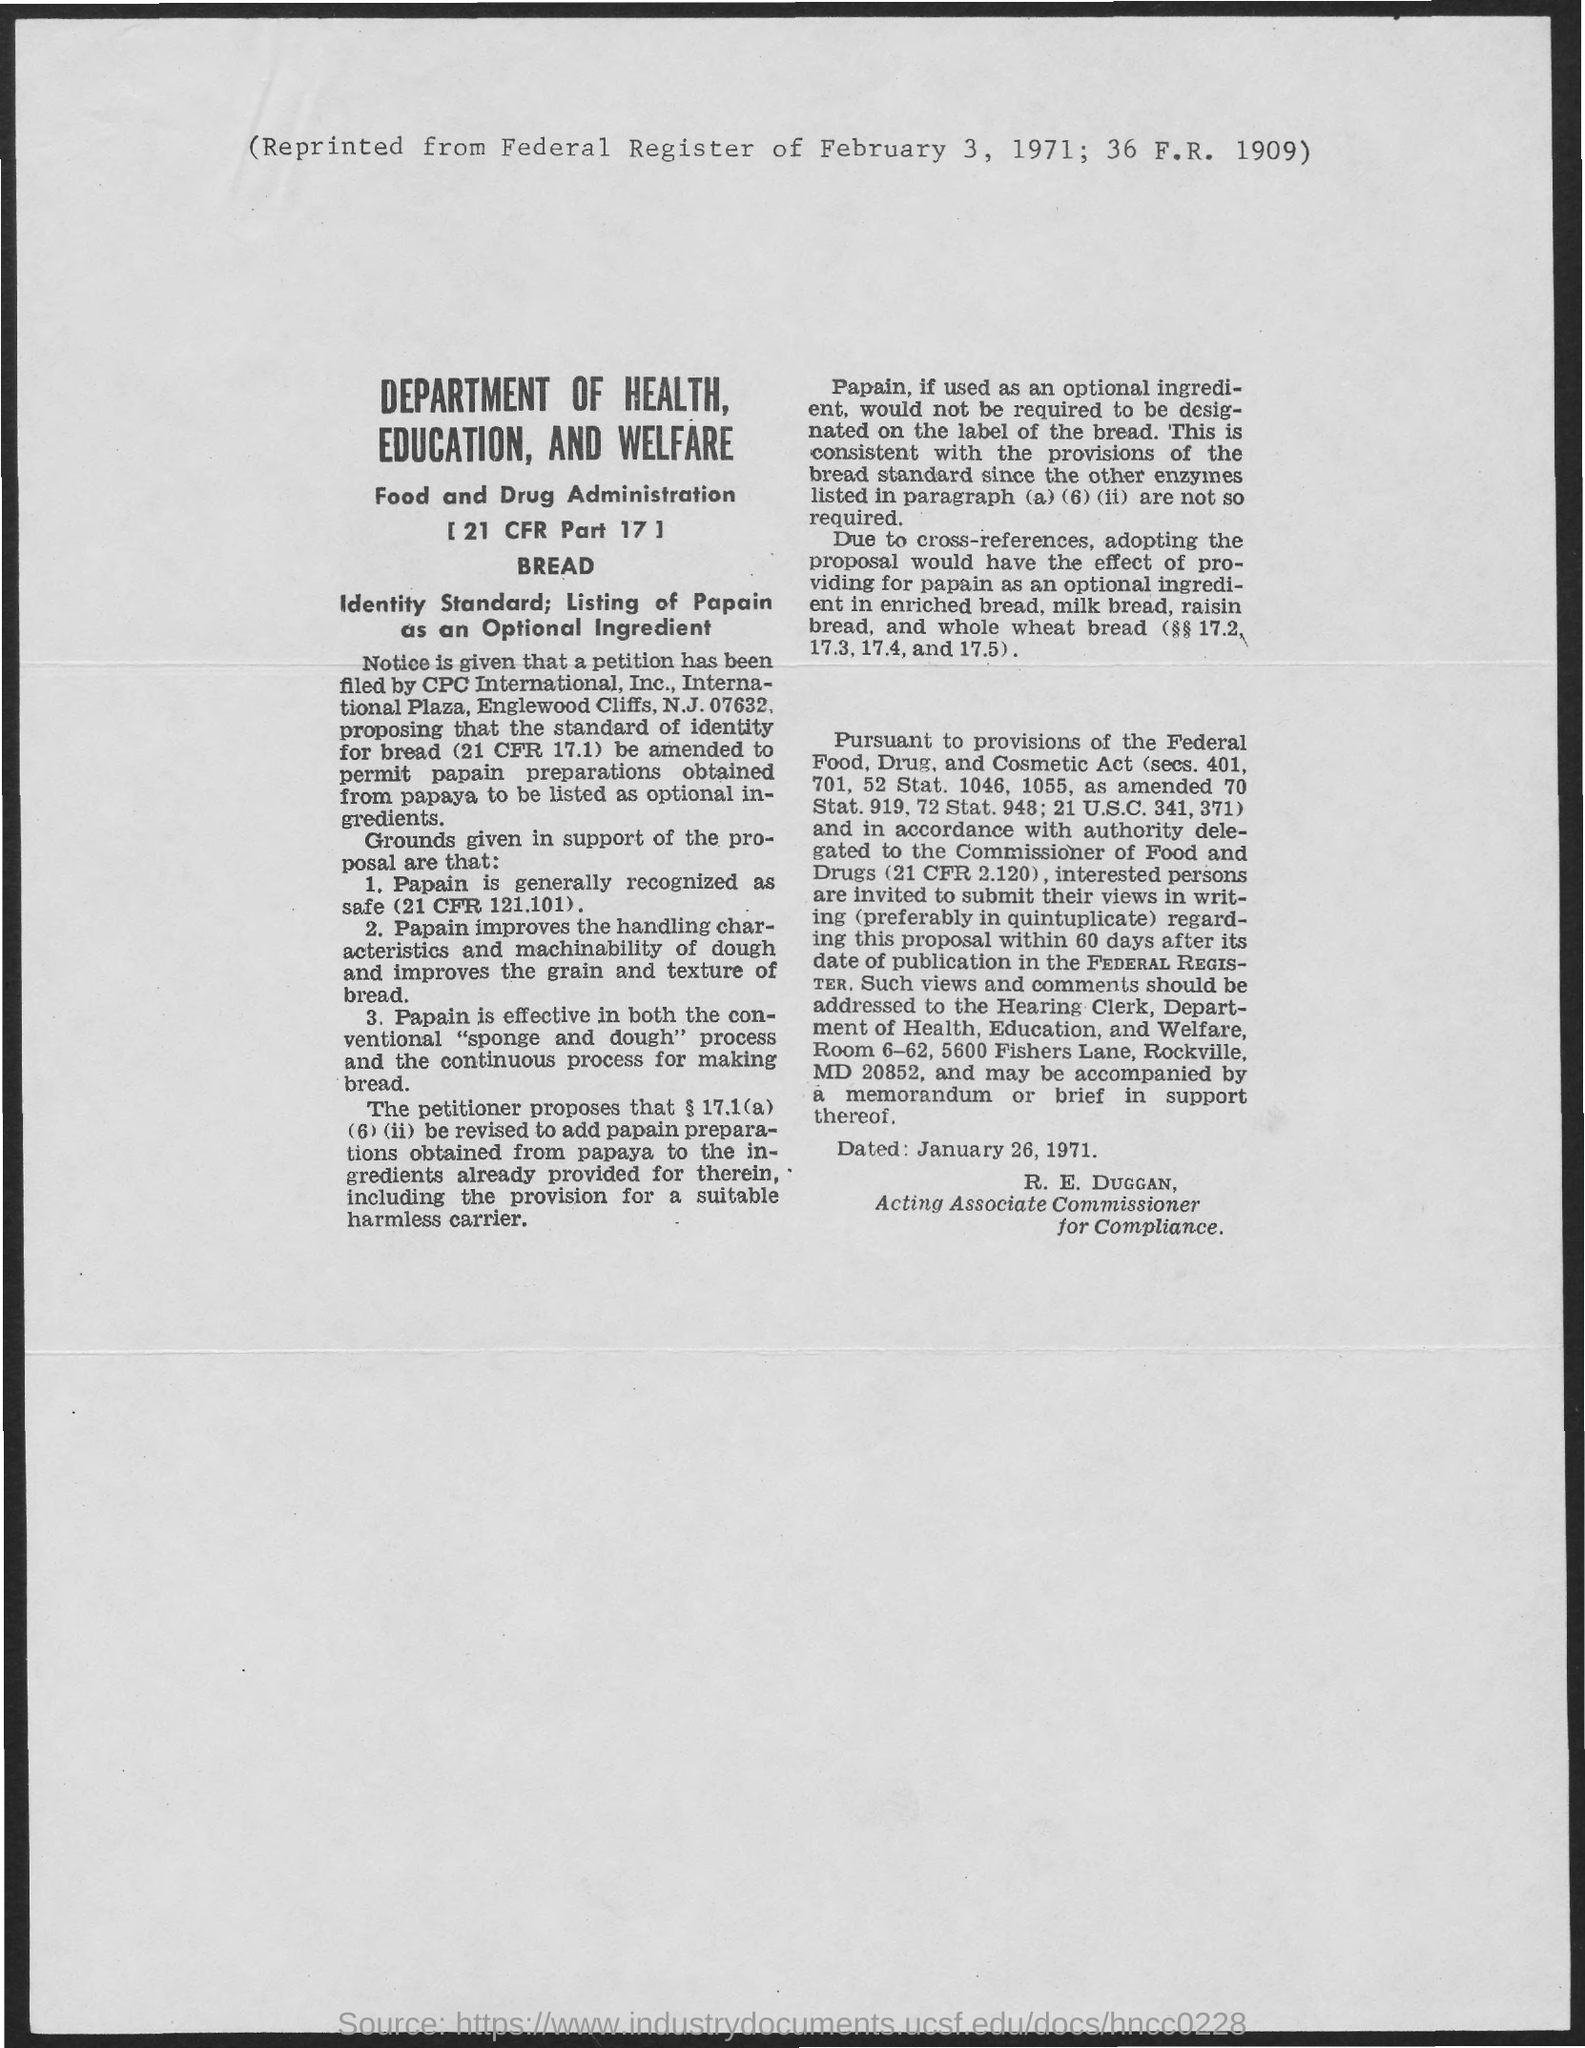Identify some key points in this picture. On February 3, 1971, the item was reprinted from the Federal Register. The date of January 26, 1971 has been established. 